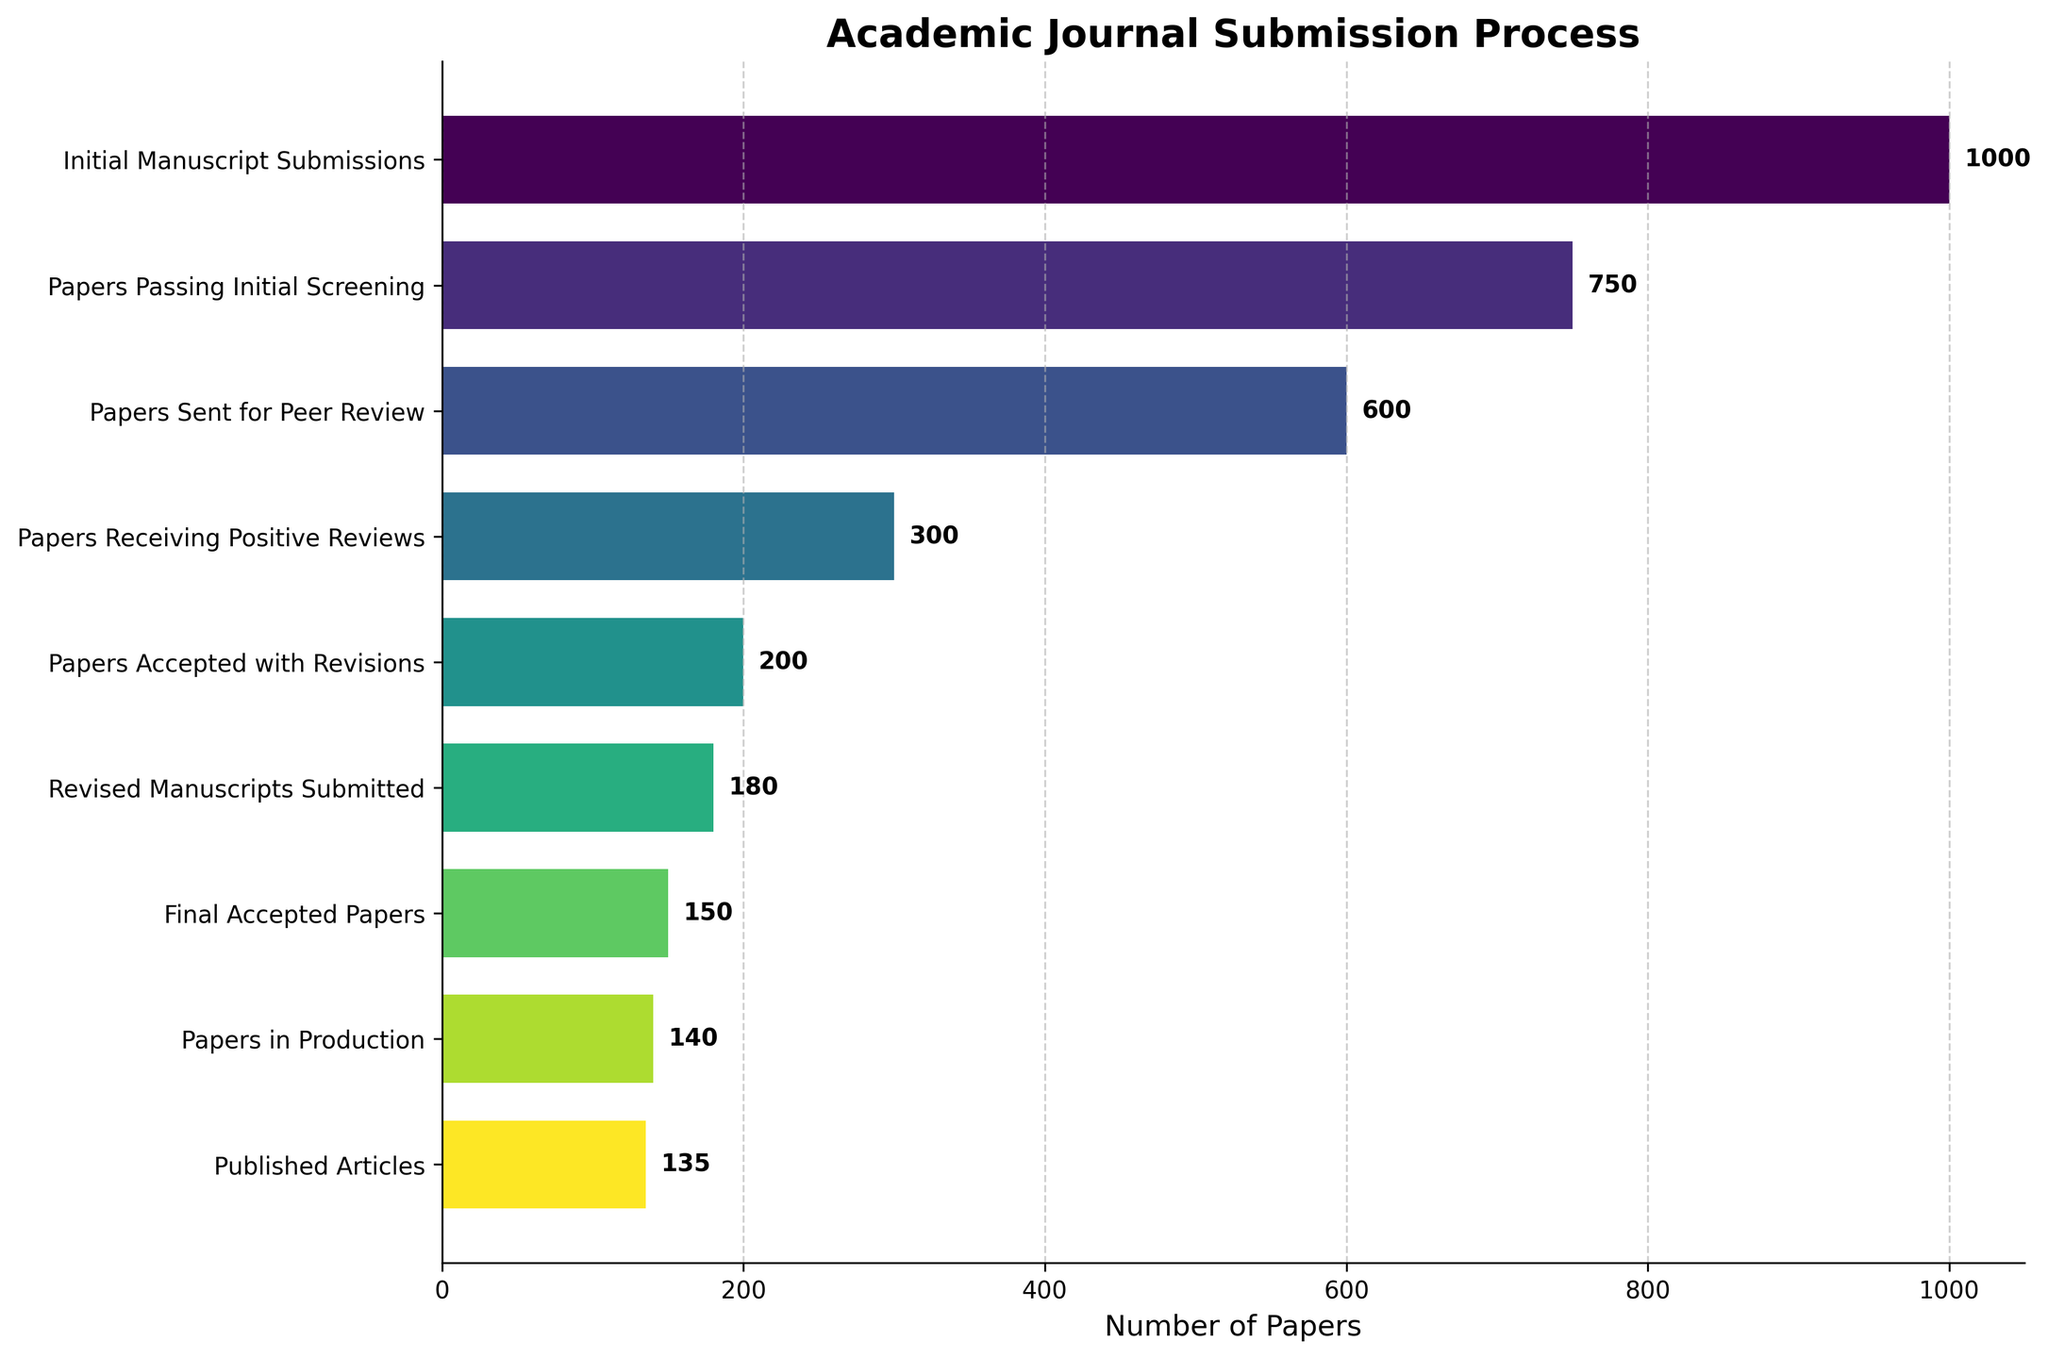What is the label of the X-axis? The X-axis label is usually found below the horizontal bars and describes what is being measured along that axis. In this figure, the X-axis measures the number of papers at each stage.
Answer: Number of Papers How many papers were initially submitted? To find the number of papers initially submitted, look at the topmost bar which corresponds to the "Initial Manuscript Submissions" stage.
Answer: 1000 Which stage sees the largest drop in the number of papers? To determine the largest drop, compare the values between consecutive stages and see where the difference is greatest. Comparing the stages, the largest drop is from "Papers Sent for Peer Review" to "Papers Receiving Positive Reviews".
Answer: 300 What is the total number of papers from Initial Manuscript Submissions to Published Articles? The total number is the sum of the values from "Initial Manuscript Submissions" to "Published Articles". 1000 + 750 + 600 + 300 + 200 + 180 + 150 + 140 + 135 = 3455
Answer: 3455 How many stages are there in the funnel chart? The number of stages is equivalent to the number of labels on the Y-axis. Count the horizontal bars or the labels on the Y-axis.
Answer: 9 What percentage of initially submitted papers end up being published? To find the percentage, divide the number of "Published Articles" by "Initial Manuscript Submissions" and multiply by 100. (135 / 1000) * 100 = 13.5%
Answer: 13.5% At which stage do a number of papers get revised before submission again? Identify the stage with 'revisions' in its label which is "Papers Accepted with Revisions" and compare it with the next stage "Revised Manuscripts Submitted".
Answer: Revised Manuscripts Submitted Between which two consecutive stages is the smallest decline in the number of papers? To find the smallest decline, calculate the differences between each pair of consecutive stages and identify the smallest difference. The smallest decline is between "Papers in Production" (140) and "Published Articles" (135) with a difference of 5.
Answer: Papers in Production to Published Articles Which stage has exactly 200 papers? Look for the stage label next to the bar that reaches the value of 200.
Answer: Papers Accepted with Revisions How many papers are sent for peer review? Look at the bar labeled “Papers Sent for Peer Review” on the y-axis and note its value.
Answer: 600 